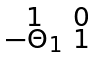<formula> <loc_0><loc_0><loc_500><loc_500>\begin{smallmatrix} 1 & 0 \\ - \Theta _ { 1 } & 1 \end{smallmatrix}</formula> 